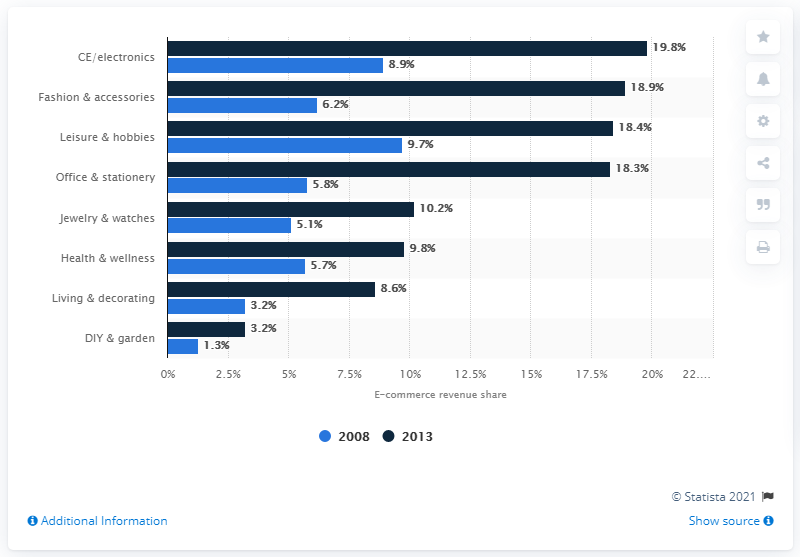Indicate a few pertinent items in this graphic. In 2013, the revenue share of online retail in Germany was 18.9%. 